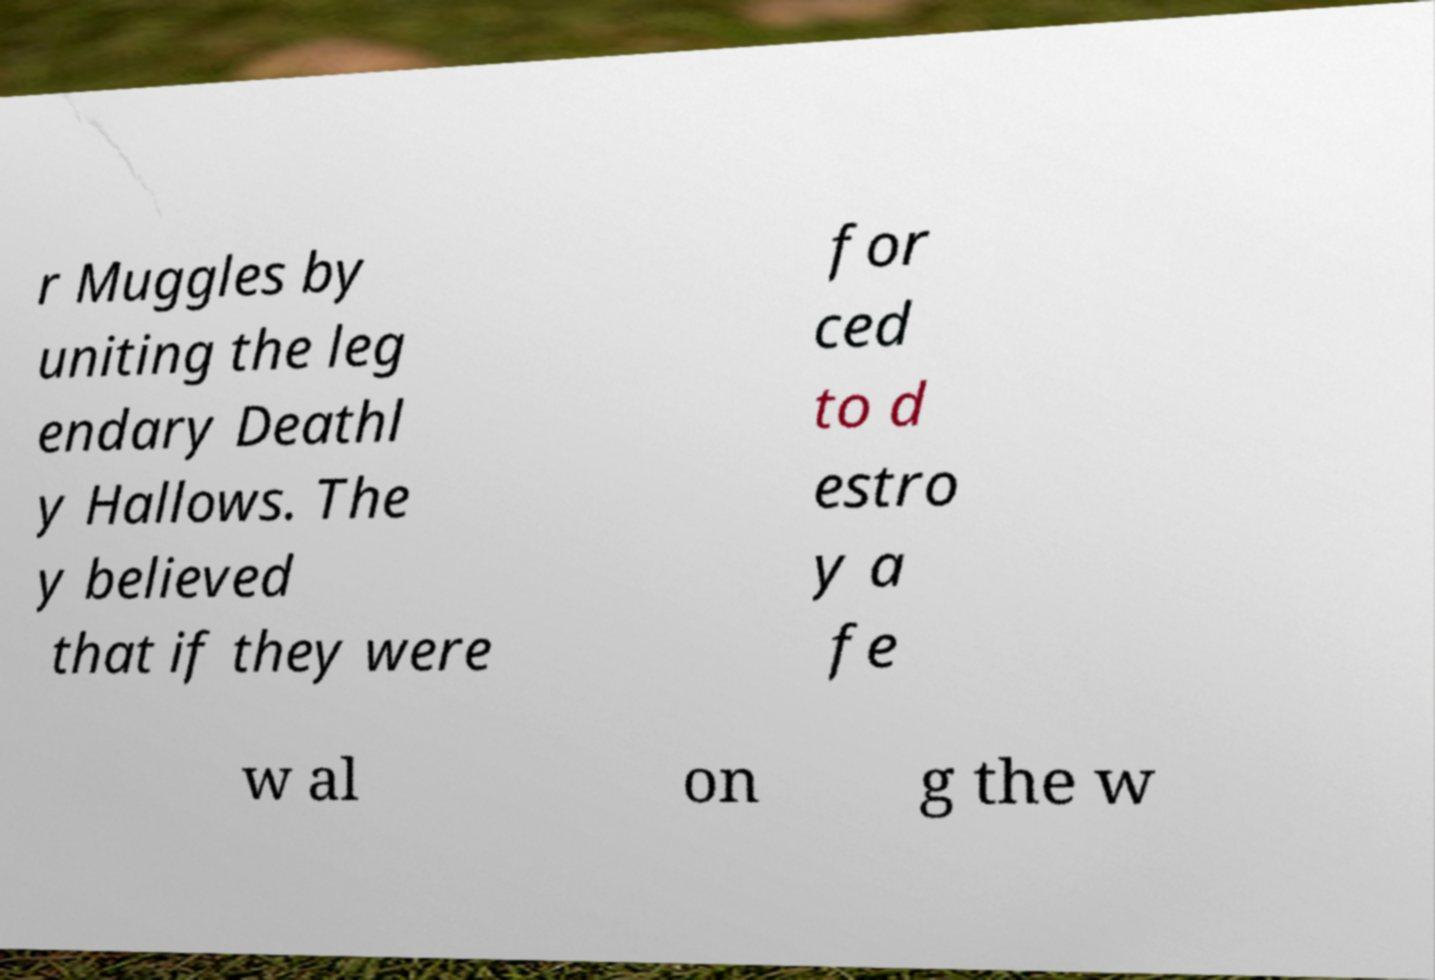Can you accurately transcribe the text from the provided image for me? r Muggles by uniting the leg endary Deathl y Hallows. The y believed that if they were for ced to d estro y a fe w al on g the w 